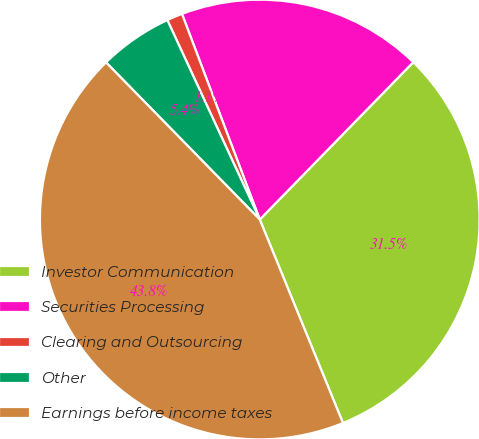Convert chart to OTSL. <chart><loc_0><loc_0><loc_500><loc_500><pie_chart><fcel>Investor Communication<fcel>Securities Processing<fcel>Clearing and Outsourcing<fcel>Other<fcel>Earnings before income taxes<nl><fcel>31.52%<fcel>18.06%<fcel>1.15%<fcel>5.42%<fcel>43.85%<nl></chart> 